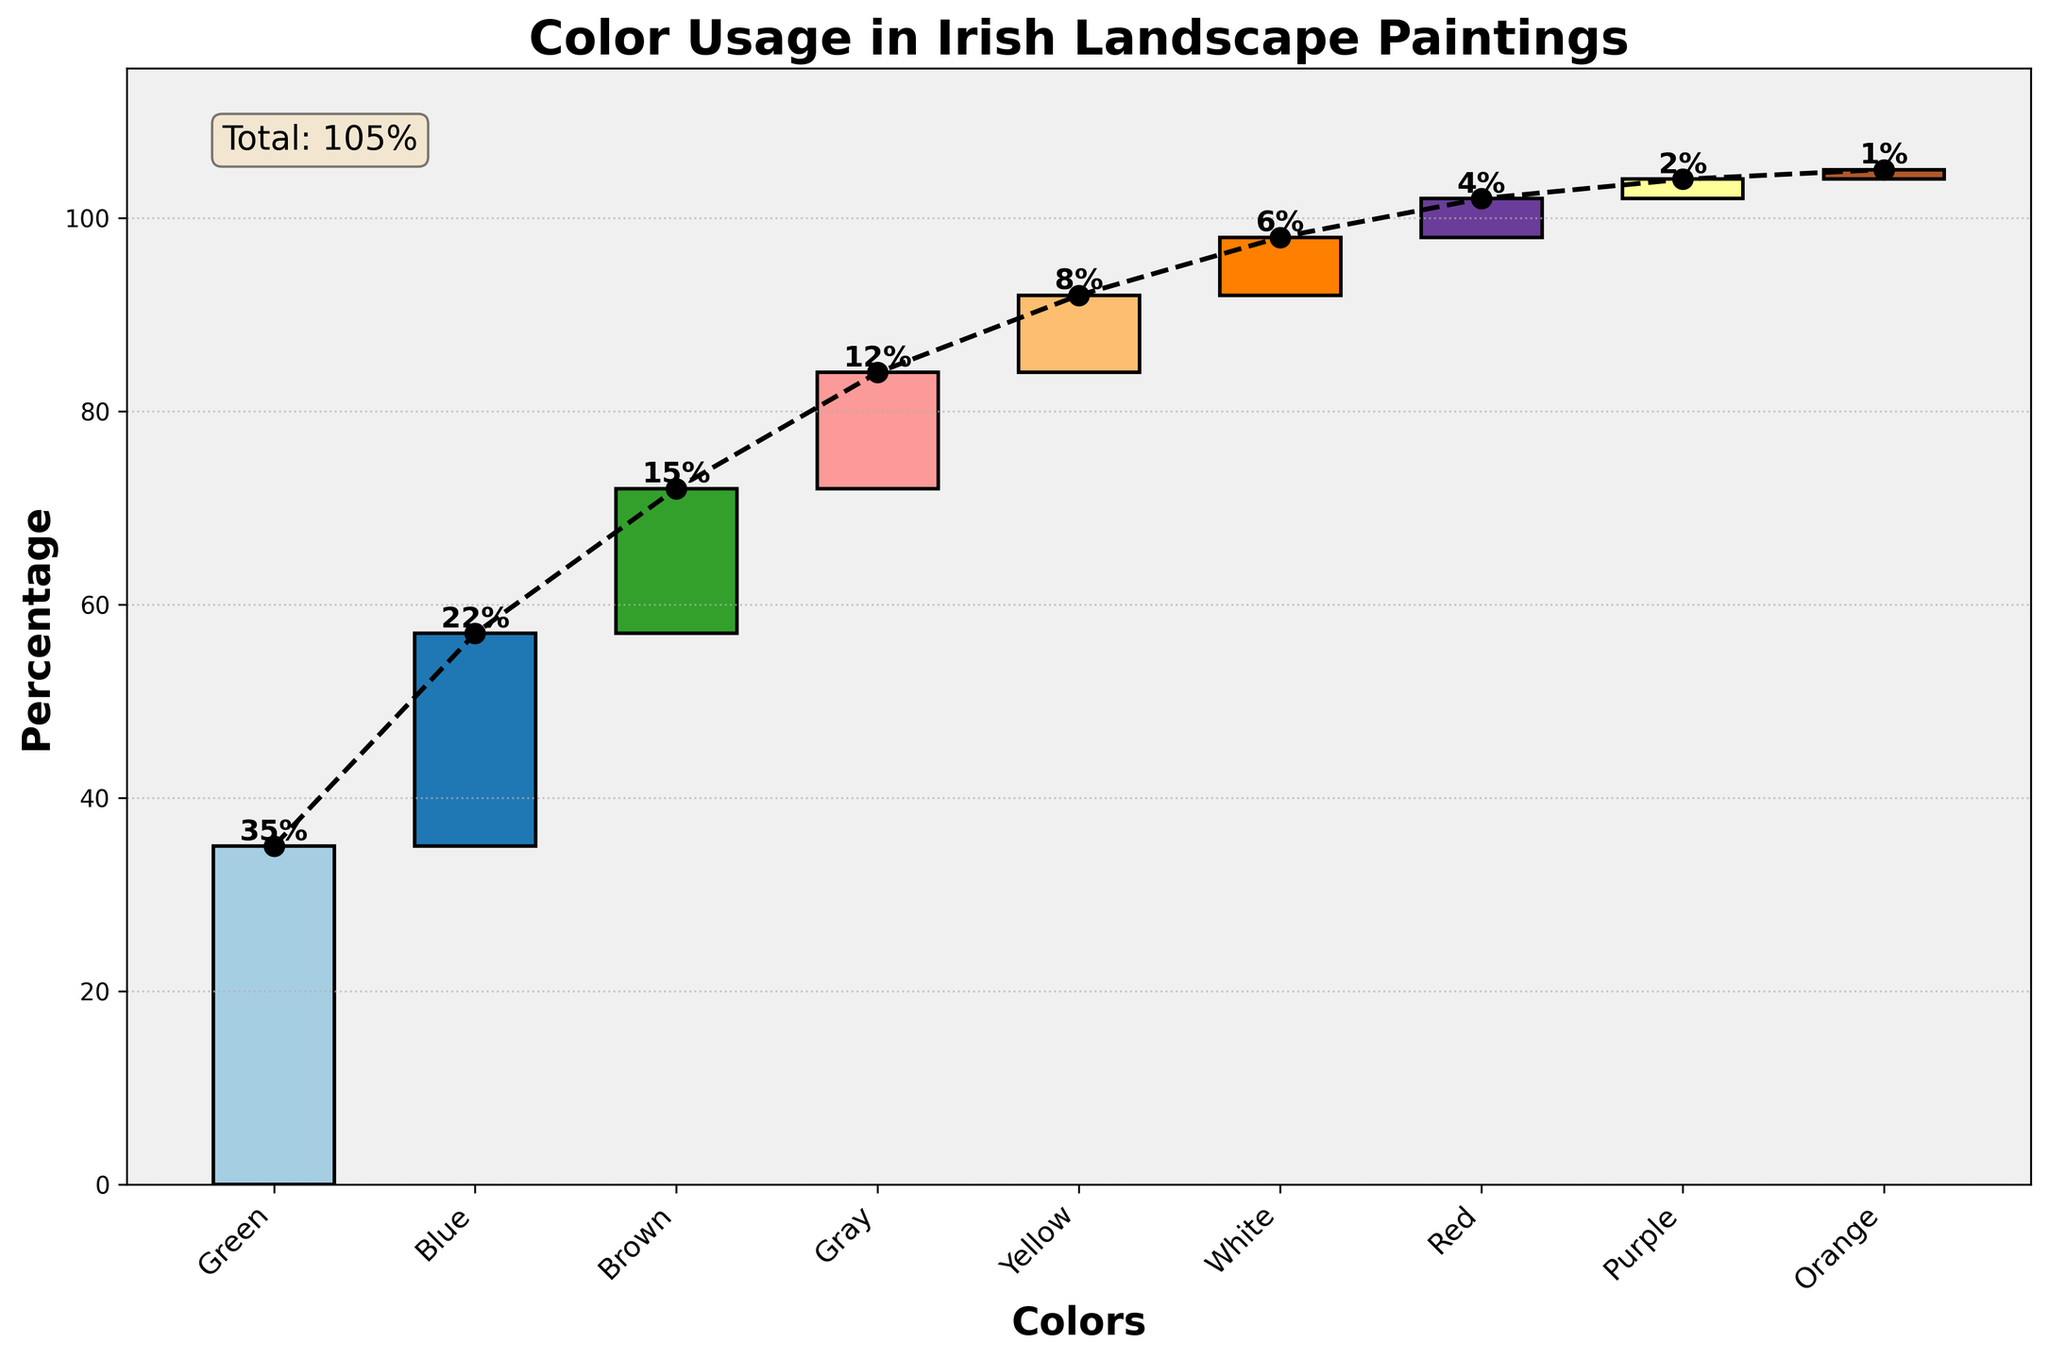Which color is used the most in Irish landscape paintings according to the chart? The chart shows the amount of each color used, with Green having the highest value at 35%.
Answer: Green What is the total percentage of color usage in the chart? The chart includes a text box indicating the total percentage, which is 105%.
Answer: 105% What is the percentage difference between the Blue and Red colors? Blue is at 22% and Red is at 4%. The difference is 22% - 4% = 18%.
Answer: 18% How do the Green and Blue colors together compare to the Total percentage? Green is 35% and Blue is 22%. Together is 35% + 22% = 57%. The Total is 105%, so they make up 57% of the total.
Answer: 57% Which color contributes the least to the total percentage? The chart shows that Orange has the smallest value at 1%.
Answer: Orange What is the combined percentage of Yellow, White, and Red? Yellow is 8%, White is 6%, and Red is 4%. Their combined percentage is 8% + 6% + 4% = 18%.
Answer: 18% How many colors are shown in the chart excluding the Total? The x-axis labels display 9 different colors, excluding the Total percentage.
Answer: 9 What is the gap difference between the Brown and Yellow color usage? Brown is at 15% and Yellow is at 8%. The difference is 15% - 8% = 7%.
Answer: 7% What is the overall trend observed from the waterfall plot? The trend showcases a step-by-step accumulation of colors leading to the Total percentage, indicating how each color contributes sequentially.
Answer: Sequential accumulation Are there more cold colors (Green, Blue, Gray) or warm colors (Brown, Yellow, Red, Orange, Purple) used in the paintings? Cold colors add up to 35% + 22% + 12% = 69%. Warm colors add up to 15% + 8% + 4% + 1% + 2% = 30%. The cold colors constitute a higher percentage.
Answer: Cold colors 